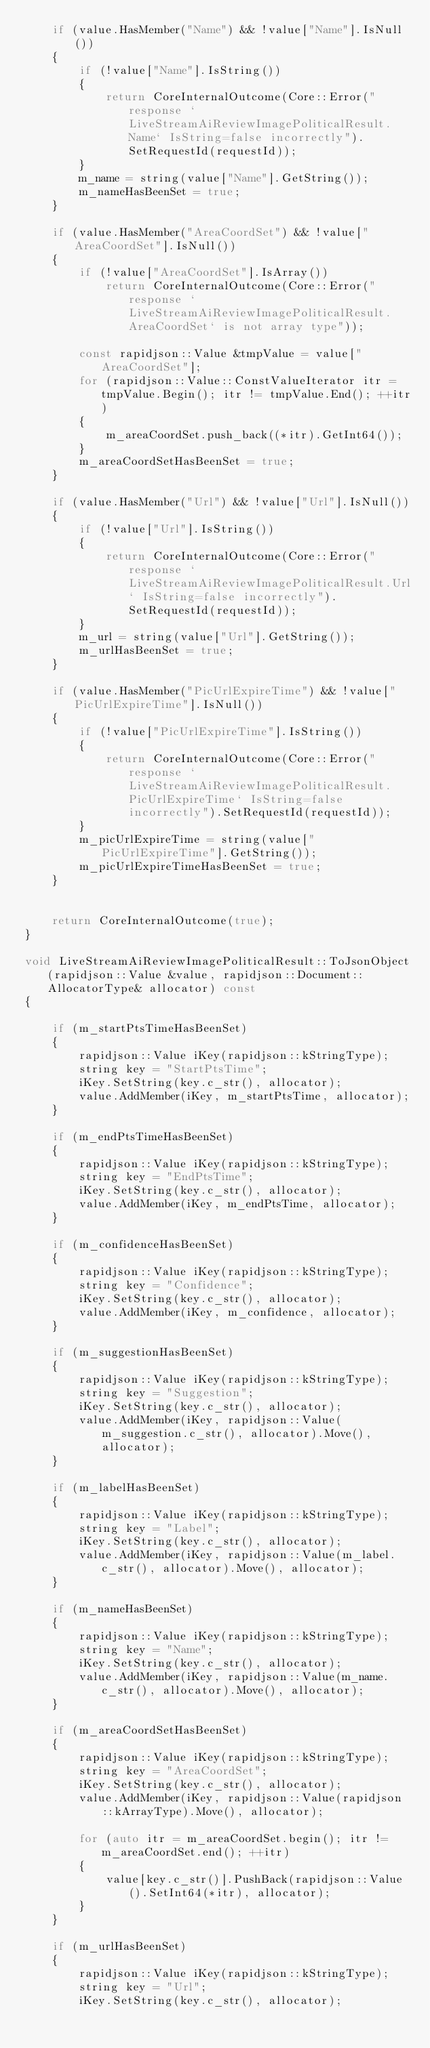Convert code to text. <code><loc_0><loc_0><loc_500><loc_500><_C++_>    if (value.HasMember("Name") && !value["Name"].IsNull())
    {
        if (!value["Name"].IsString())
        {
            return CoreInternalOutcome(Core::Error("response `LiveStreamAiReviewImagePoliticalResult.Name` IsString=false incorrectly").SetRequestId(requestId));
        }
        m_name = string(value["Name"].GetString());
        m_nameHasBeenSet = true;
    }

    if (value.HasMember("AreaCoordSet") && !value["AreaCoordSet"].IsNull())
    {
        if (!value["AreaCoordSet"].IsArray())
            return CoreInternalOutcome(Core::Error("response `LiveStreamAiReviewImagePoliticalResult.AreaCoordSet` is not array type"));

        const rapidjson::Value &tmpValue = value["AreaCoordSet"];
        for (rapidjson::Value::ConstValueIterator itr = tmpValue.Begin(); itr != tmpValue.End(); ++itr)
        {
            m_areaCoordSet.push_back((*itr).GetInt64());
        }
        m_areaCoordSetHasBeenSet = true;
    }

    if (value.HasMember("Url") && !value["Url"].IsNull())
    {
        if (!value["Url"].IsString())
        {
            return CoreInternalOutcome(Core::Error("response `LiveStreamAiReviewImagePoliticalResult.Url` IsString=false incorrectly").SetRequestId(requestId));
        }
        m_url = string(value["Url"].GetString());
        m_urlHasBeenSet = true;
    }

    if (value.HasMember("PicUrlExpireTime") && !value["PicUrlExpireTime"].IsNull())
    {
        if (!value["PicUrlExpireTime"].IsString())
        {
            return CoreInternalOutcome(Core::Error("response `LiveStreamAiReviewImagePoliticalResult.PicUrlExpireTime` IsString=false incorrectly").SetRequestId(requestId));
        }
        m_picUrlExpireTime = string(value["PicUrlExpireTime"].GetString());
        m_picUrlExpireTimeHasBeenSet = true;
    }


    return CoreInternalOutcome(true);
}

void LiveStreamAiReviewImagePoliticalResult::ToJsonObject(rapidjson::Value &value, rapidjson::Document::AllocatorType& allocator) const
{

    if (m_startPtsTimeHasBeenSet)
    {
        rapidjson::Value iKey(rapidjson::kStringType);
        string key = "StartPtsTime";
        iKey.SetString(key.c_str(), allocator);
        value.AddMember(iKey, m_startPtsTime, allocator);
    }

    if (m_endPtsTimeHasBeenSet)
    {
        rapidjson::Value iKey(rapidjson::kStringType);
        string key = "EndPtsTime";
        iKey.SetString(key.c_str(), allocator);
        value.AddMember(iKey, m_endPtsTime, allocator);
    }

    if (m_confidenceHasBeenSet)
    {
        rapidjson::Value iKey(rapidjson::kStringType);
        string key = "Confidence";
        iKey.SetString(key.c_str(), allocator);
        value.AddMember(iKey, m_confidence, allocator);
    }

    if (m_suggestionHasBeenSet)
    {
        rapidjson::Value iKey(rapidjson::kStringType);
        string key = "Suggestion";
        iKey.SetString(key.c_str(), allocator);
        value.AddMember(iKey, rapidjson::Value(m_suggestion.c_str(), allocator).Move(), allocator);
    }

    if (m_labelHasBeenSet)
    {
        rapidjson::Value iKey(rapidjson::kStringType);
        string key = "Label";
        iKey.SetString(key.c_str(), allocator);
        value.AddMember(iKey, rapidjson::Value(m_label.c_str(), allocator).Move(), allocator);
    }

    if (m_nameHasBeenSet)
    {
        rapidjson::Value iKey(rapidjson::kStringType);
        string key = "Name";
        iKey.SetString(key.c_str(), allocator);
        value.AddMember(iKey, rapidjson::Value(m_name.c_str(), allocator).Move(), allocator);
    }

    if (m_areaCoordSetHasBeenSet)
    {
        rapidjson::Value iKey(rapidjson::kStringType);
        string key = "AreaCoordSet";
        iKey.SetString(key.c_str(), allocator);
        value.AddMember(iKey, rapidjson::Value(rapidjson::kArrayType).Move(), allocator);

        for (auto itr = m_areaCoordSet.begin(); itr != m_areaCoordSet.end(); ++itr)
        {
            value[key.c_str()].PushBack(rapidjson::Value().SetInt64(*itr), allocator);
        }
    }

    if (m_urlHasBeenSet)
    {
        rapidjson::Value iKey(rapidjson::kStringType);
        string key = "Url";
        iKey.SetString(key.c_str(), allocator);</code> 